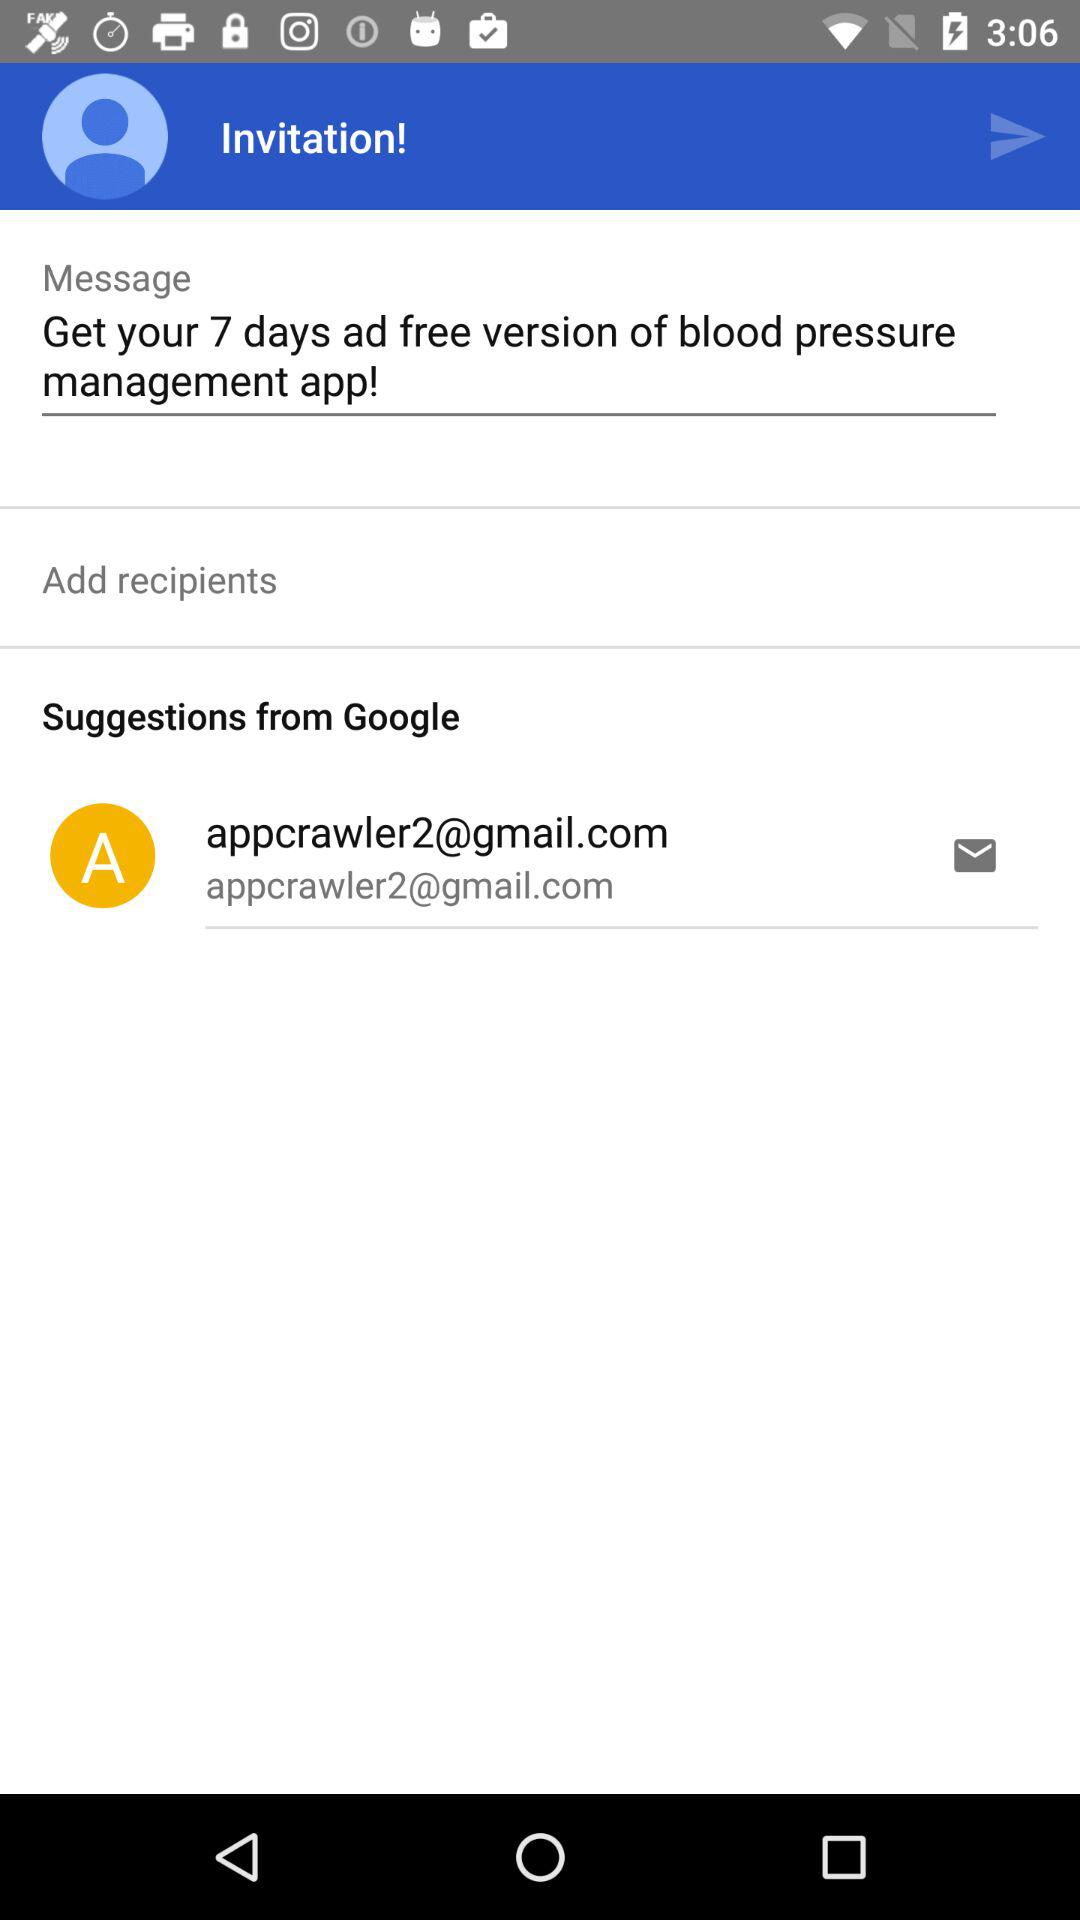For how many days is the free version of the blood pressure management app available? The free version of the blood pressure management app is available for 7 days. 